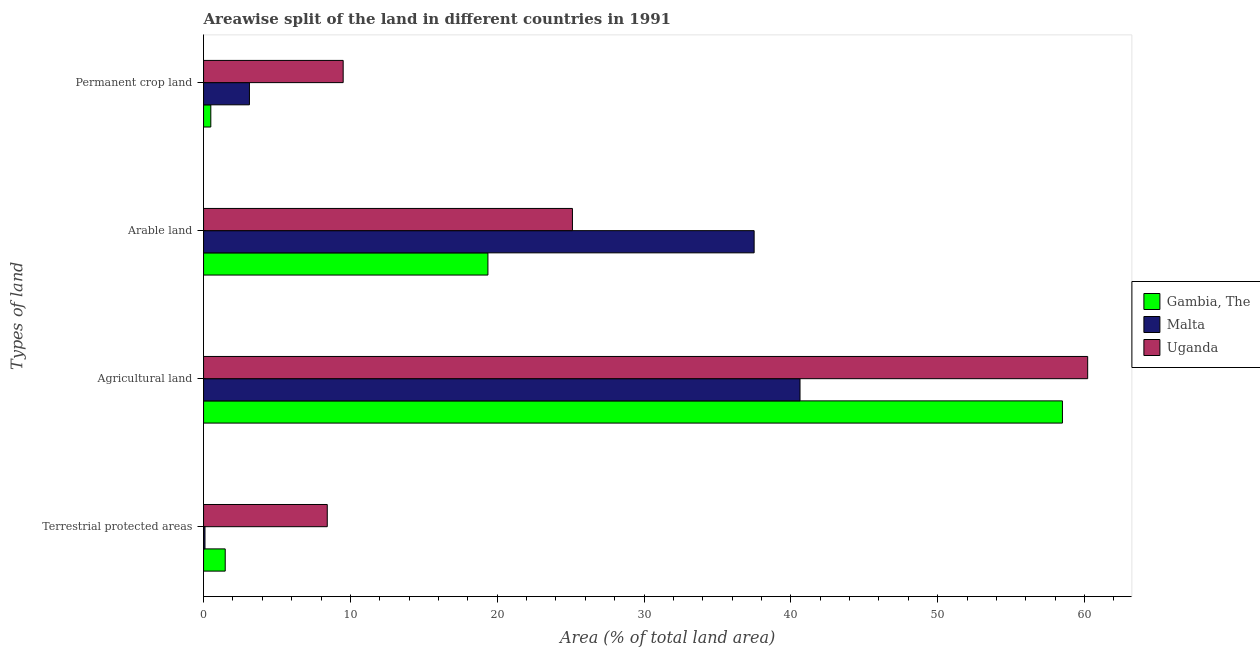How many different coloured bars are there?
Keep it short and to the point. 3. Are the number of bars on each tick of the Y-axis equal?
Your answer should be compact. Yes. How many bars are there on the 1st tick from the top?
Ensure brevity in your answer.  3. How many bars are there on the 3rd tick from the bottom?
Your answer should be very brief. 3. What is the label of the 3rd group of bars from the top?
Keep it short and to the point. Agricultural land. What is the percentage of area under permanent crop land in Uganda?
Ensure brevity in your answer.  9.51. Across all countries, what is the maximum percentage of land under terrestrial protection?
Ensure brevity in your answer.  8.43. Across all countries, what is the minimum percentage of area under permanent crop land?
Offer a very short reply. 0.49. In which country was the percentage of land under terrestrial protection maximum?
Offer a very short reply. Uganda. In which country was the percentage of area under agricultural land minimum?
Keep it short and to the point. Malta. What is the total percentage of land under terrestrial protection in the graph?
Your answer should be compact. 10. What is the difference between the percentage of area under permanent crop land in Gambia, The and that in Uganda?
Offer a terse response. -9.01. What is the difference between the percentage of area under arable land in Gambia, The and the percentage of land under terrestrial protection in Uganda?
Offer a terse response. 10.94. What is the average percentage of area under arable land per country?
Keep it short and to the point. 27.33. What is the difference between the percentage of area under agricultural land and percentage of area under arable land in Uganda?
Make the answer very short. 35.09. In how many countries, is the percentage of area under arable land greater than 12 %?
Give a very brief answer. 3. What is the ratio of the percentage of area under arable land in Uganda to that in Gambia, The?
Offer a terse response. 1.3. Is the percentage of area under arable land in Gambia, The less than that in Malta?
Ensure brevity in your answer.  Yes. Is the difference between the percentage of area under agricultural land in Malta and Gambia, The greater than the difference between the percentage of area under arable land in Malta and Gambia, The?
Your answer should be very brief. No. What is the difference between the highest and the second highest percentage of area under permanent crop land?
Provide a succinct answer. 6.38. What is the difference between the highest and the lowest percentage of area under permanent crop land?
Provide a succinct answer. 9.01. In how many countries, is the percentage of area under permanent crop land greater than the average percentage of area under permanent crop land taken over all countries?
Your response must be concise. 1. Is it the case that in every country, the sum of the percentage of area under agricultural land and percentage of area under permanent crop land is greater than the sum of percentage of land under terrestrial protection and percentage of area under arable land?
Your response must be concise. No. What does the 2nd bar from the top in Terrestrial protected areas represents?
Your response must be concise. Malta. What does the 3rd bar from the bottom in Agricultural land represents?
Ensure brevity in your answer.  Uganda. Are all the bars in the graph horizontal?
Keep it short and to the point. Yes. How many countries are there in the graph?
Offer a terse response. 3. Are the values on the major ticks of X-axis written in scientific E-notation?
Offer a terse response. No. Does the graph contain any zero values?
Your answer should be compact. No. Does the graph contain grids?
Ensure brevity in your answer.  No. How many legend labels are there?
Keep it short and to the point. 3. How are the legend labels stacked?
Offer a terse response. Vertical. What is the title of the graph?
Provide a short and direct response. Areawise split of the land in different countries in 1991. What is the label or title of the X-axis?
Make the answer very short. Area (% of total land area). What is the label or title of the Y-axis?
Ensure brevity in your answer.  Types of land. What is the Area (% of total land area) in Gambia, The in Terrestrial protected areas?
Your answer should be compact. 1.48. What is the Area (% of total land area) in Malta in Terrestrial protected areas?
Offer a terse response. 0.1. What is the Area (% of total land area) of Uganda in Terrestrial protected areas?
Offer a very short reply. 8.43. What is the Area (% of total land area) in Gambia, The in Agricultural land?
Give a very brief answer. 58.5. What is the Area (% of total land area) of Malta in Agricultural land?
Provide a short and direct response. 40.62. What is the Area (% of total land area) of Uganda in Agricultural land?
Offer a terse response. 60.22. What is the Area (% of total land area) in Gambia, The in Arable land?
Keep it short and to the point. 19.37. What is the Area (% of total land area) in Malta in Arable land?
Your answer should be very brief. 37.5. What is the Area (% of total land area) in Uganda in Arable land?
Ensure brevity in your answer.  25.12. What is the Area (% of total land area) in Gambia, The in Permanent crop land?
Your answer should be compact. 0.49. What is the Area (% of total land area) in Malta in Permanent crop land?
Ensure brevity in your answer.  3.12. What is the Area (% of total land area) in Uganda in Permanent crop land?
Keep it short and to the point. 9.51. Across all Types of land, what is the maximum Area (% of total land area) in Gambia, The?
Give a very brief answer. 58.5. Across all Types of land, what is the maximum Area (% of total land area) of Malta?
Your response must be concise. 40.62. Across all Types of land, what is the maximum Area (% of total land area) of Uganda?
Provide a succinct answer. 60.22. Across all Types of land, what is the minimum Area (% of total land area) of Gambia, The?
Make the answer very short. 0.49. Across all Types of land, what is the minimum Area (% of total land area) of Malta?
Provide a short and direct response. 0.1. Across all Types of land, what is the minimum Area (% of total land area) in Uganda?
Provide a succinct answer. 8.43. What is the total Area (% of total land area) in Gambia, The in the graph?
Ensure brevity in your answer.  79.83. What is the total Area (% of total land area) in Malta in the graph?
Offer a terse response. 81.35. What is the total Area (% of total land area) in Uganda in the graph?
Your response must be concise. 103.28. What is the difference between the Area (% of total land area) of Gambia, The in Terrestrial protected areas and that in Agricultural land?
Make the answer very short. -57.02. What is the difference between the Area (% of total land area) of Malta in Terrestrial protected areas and that in Agricultural land?
Ensure brevity in your answer.  -40.53. What is the difference between the Area (% of total land area) of Uganda in Terrestrial protected areas and that in Agricultural land?
Your response must be concise. -51.79. What is the difference between the Area (% of total land area) in Gambia, The in Terrestrial protected areas and that in Arable land?
Ensure brevity in your answer.  -17.89. What is the difference between the Area (% of total land area) of Malta in Terrestrial protected areas and that in Arable land?
Provide a short and direct response. -37.4. What is the difference between the Area (% of total land area) in Uganda in Terrestrial protected areas and that in Arable land?
Keep it short and to the point. -16.7. What is the difference between the Area (% of total land area) of Gambia, The in Terrestrial protected areas and that in Permanent crop land?
Keep it short and to the point. 0.98. What is the difference between the Area (% of total land area) in Malta in Terrestrial protected areas and that in Permanent crop land?
Give a very brief answer. -3.03. What is the difference between the Area (% of total land area) of Uganda in Terrestrial protected areas and that in Permanent crop land?
Give a very brief answer. -1.08. What is the difference between the Area (% of total land area) of Gambia, The in Agricultural land and that in Arable land?
Make the answer very short. 39.13. What is the difference between the Area (% of total land area) in Malta in Agricultural land and that in Arable land?
Make the answer very short. 3.12. What is the difference between the Area (% of total land area) in Uganda in Agricultural land and that in Arable land?
Provide a short and direct response. 35.09. What is the difference between the Area (% of total land area) of Gambia, The in Agricultural land and that in Permanent crop land?
Your answer should be very brief. 58. What is the difference between the Area (% of total land area) in Malta in Agricultural land and that in Permanent crop land?
Offer a very short reply. 37.5. What is the difference between the Area (% of total land area) of Uganda in Agricultural land and that in Permanent crop land?
Your answer should be compact. 50.71. What is the difference between the Area (% of total land area) of Gambia, The in Arable land and that in Permanent crop land?
Ensure brevity in your answer.  18.87. What is the difference between the Area (% of total land area) of Malta in Arable land and that in Permanent crop land?
Offer a terse response. 34.38. What is the difference between the Area (% of total land area) in Uganda in Arable land and that in Permanent crop land?
Provide a short and direct response. 15.61. What is the difference between the Area (% of total land area) in Gambia, The in Terrestrial protected areas and the Area (% of total land area) in Malta in Agricultural land?
Your answer should be very brief. -39.15. What is the difference between the Area (% of total land area) of Gambia, The in Terrestrial protected areas and the Area (% of total land area) of Uganda in Agricultural land?
Ensure brevity in your answer.  -58.74. What is the difference between the Area (% of total land area) of Malta in Terrestrial protected areas and the Area (% of total land area) of Uganda in Agricultural land?
Offer a terse response. -60.12. What is the difference between the Area (% of total land area) in Gambia, The in Terrestrial protected areas and the Area (% of total land area) in Malta in Arable land?
Provide a succinct answer. -36.02. What is the difference between the Area (% of total land area) in Gambia, The in Terrestrial protected areas and the Area (% of total land area) in Uganda in Arable land?
Keep it short and to the point. -23.65. What is the difference between the Area (% of total land area) of Malta in Terrestrial protected areas and the Area (% of total land area) of Uganda in Arable land?
Give a very brief answer. -25.03. What is the difference between the Area (% of total land area) of Gambia, The in Terrestrial protected areas and the Area (% of total land area) of Malta in Permanent crop land?
Your response must be concise. -1.65. What is the difference between the Area (% of total land area) of Gambia, The in Terrestrial protected areas and the Area (% of total land area) of Uganda in Permanent crop land?
Provide a succinct answer. -8.03. What is the difference between the Area (% of total land area) of Malta in Terrestrial protected areas and the Area (% of total land area) of Uganda in Permanent crop land?
Provide a short and direct response. -9.41. What is the difference between the Area (% of total land area) in Gambia, The in Agricultural land and the Area (% of total land area) in Malta in Arable land?
Provide a short and direct response. 21. What is the difference between the Area (% of total land area) in Gambia, The in Agricultural land and the Area (% of total land area) in Uganda in Arable land?
Give a very brief answer. 33.37. What is the difference between the Area (% of total land area) in Malta in Agricultural land and the Area (% of total land area) in Uganda in Arable land?
Ensure brevity in your answer.  15.5. What is the difference between the Area (% of total land area) in Gambia, The in Agricultural land and the Area (% of total land area) in Malta in Permanent crop land?
Offer a terse response. 55.37. What is the difference between the Area (% of total land area) of Gambia, The in Agricultural land and the Area (% of total land area) of Uganda in Permanent crop land?
Offer a very short reply. 48.99. What is the difference between the Area (% of total land area) in Malta in Agricultural land and the Area (% of total land area) in Uganda in Permanent crop land?
Provide a succinct answer. 31.12. What is the difference between the Area (% of total land area) of Gambia, The in Arable land and the Area (% of total land area) of Malta in Permanent crop land?
Your answer should be compact. 16.24. What is the difference between the Area (% of total land area) of Gambia, The in Arable land and the Area (% of total land area) of Uganda in Permanent crop land?
Your answer should be very brief. 9.86. What is the difference between the Area (% of total land area) in Malta in Arable land and the Area (% of total land area) in Uganda in Permanent crop land?
Provide a short and direct response. 27.99. What is the average Area (% of total land area) of Gambia, The per Types of land?
Make the answer very short. 19.96. What is the average Area (% of total land area) of Malta per Types of land?
Ensure brevity in your answer.  20.34. What is the average Area (% of total land area) of Uganda per Types of land?
Keep it short and to the point. 25.82. What is the difference between the Area (% of total land area) of Gambia, The and Area (% of total land area) of Malta in Terrestrial protected areas?
Keep it short and to the point. 1.38. What is the difference between the Area (% of total land area) of Gambia, The and Area (% of total land area) of Uganda in Terrestrial protected areas?
Make the answer very short. -6.95. What is the difference between the Area (% of total land area) in Malta and Area (% of total land area) in Uganda in Terrestrial protected areas?
Ensure brevity in your answer.  -8.33. What is the difference between the Area (% of total land area) of Gambia, The and Area (% of total land area) of Malta in Agricultural land?
Provide a succinct answer. 17.87. What is the difference between the Area (% of total land area) in Gambia, The and Area (% of total land area) in Uganda in Agricultural land?
Keep it short and to the point. -1.72. What is the difference between the Area (% of total land area) of Malta and Area (% of total land area) of Uganda in Agricultural land?
Provide a succinct answer. -19.59. What is the difference between the Area (% of total land area) of Gambia, The and Area (% of total land area) of Malta in Arable land?
Offer a very short reply. -18.13. What is the difference between the Area (% of total land area) of Gambia, The and Area (% of total land area) of Uganda in Arable land?
Provide a succinct answer. -5.76. What is the difference between the Area (% of total land area) in Malta and Area (% of total land area) in Uganda in Arable land?
Your answer should be very brief. 12.38. What is the difference between the Area (% of total land area) in Gambia, The and Area (% of total land area) in Malta in Permanent crop land?
Ensure brevity in your answer.  -2.63. What is the difference between the Area (% of total land area) in Gambia, The and Area (% of total land area) in Uganda in Permanent crop land?
Provide a short and direct response. -9.02. What is the difference between the Area (% of total land area) of Malta and Area (% of total land area) of Uganda in Permanent crop land?
Offer a terse response. -6.38. What is the ratio of the Area (% of total land area) in Gambia, The in Terrestrial protected areas to that in Agricultural land?
Give a very brief answer. 0.03. What is the ratio of the Area (% of total land area) of Malta in Terrestrial protected areas to that in Agricultural land?
Offer a terse response. 0. What is the ratio of the Area (% of total land area) in Uganda in Terrestrial protected areas to that in Agricultural land?
Make the answer very short. 0.14. What is the ratio of the Area (% of total land area) of Gambia, The in Terrestrial protected areas to that in Arable land?
Your response must be concise. 0.08. What is the ratio of the Area (% of total land area) in Malta in Terrestrial protected areas to that in Arable land?
Your answer should be very brief. 0. What is the ratio of the Area (% of total land area) in Uganda in Terrestrial protected areas to that in Arable land?
Offer a very short reply. 0.34. What is the ratio of the Area (% of total land area) of Gambia, The in Terrestrial protected areas to that in Permanent crop land?
Make the answer very short. 2.99. What is the ratio of the Area (% of total land area) in Malta in Terrestrial protected areas to that in Permanent crop land?
Offer a very short reply. 0.03. What is the ratio of the Area (% of total land area) of Uganda in Terrestrial protected areas to that in Permanent crop land?
Give a very brief answer. 0.89. What is the ratio of the Area (% of total land area) of Gambia, The in Agricultural land to that in Arable land?
Ensure brevity in your answer.  3.02. What is the ratio of the Area (% of total land area) of Uganda in Agricultural land to that in Arable land?
Provide a succinct answer. 2.4. What is the ratio of the Area (% of total land area) of Gambia, The in Agricultural land to that in Permanent crop land?
Your answer should be very brief. 118.4. What is the ratio of the Area (% of total land area) of Malta in Agricultural land to that in Permanent crop land?
Provide a short and direct response. 13. What is the ratio of the Area (% of total land area) of Uganda in Agricultural land to that in Permanent crop land?
Your answer should be very brief. 6.33. What is the ratio of the Area (% of total land area) of Gambia, The in Arable land to that in Permanent crop land?
Ensure brevity in your answer.  39.2. What is the ratio of the Area (% of total land area) in Uganda in Arable land to that in Permanent crop land?
Your answer should be very brief. 2.64. What is the difference between the highest and the second highest Area (% of total land area) of Gambia, The?
Offer a very short reply. 39.13. What is the difference between the highest and the second highest Area (% of total land area) of Malta?
Offer a terse response. 3.12. What is the difference between the highest and the second highest Area (% of total land area) in Uganda?
Provide a succinct answer. 35.09. What is the difference between the highest and the lowest Area (% of total land area) of Gambia, The?
Provide a succinct answer. 58. What is the difference between the highest and the lowest Area (% of total land area) in Malta?
Offer a very short reply. 40.53. What is the difference between the highest and the lowest Area (% of total land area) in Uganda?
Provide a succinct answer. 51.79. 